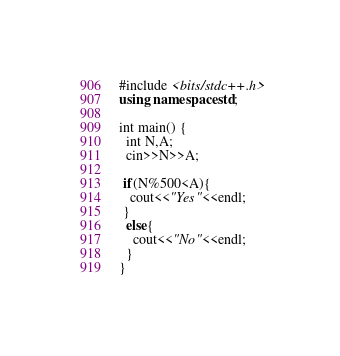<code> <loc_0><loc_0><loc_500><loc_500><_C++_>#include <bits/stdc++.h>
using namespace std;

int main() {
  int N,A;
  cin>>N>>A;
  
 if(N%500<A){
   cout<<"Yes"<<endl;
 }
  else{
    cout<<"No"<<endl;
  } 
}
</code> 